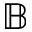<formula> <loc_0><loc_0><loc_500><loc_500>\mathbb { B }</formula> 